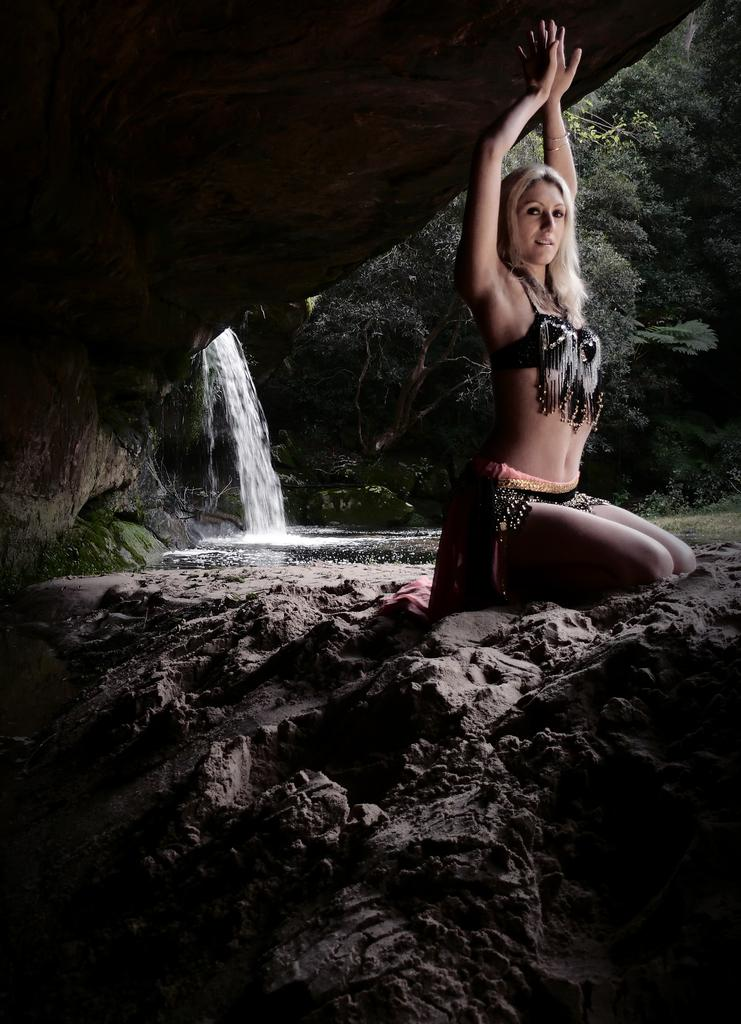Who or what is present in the image? There is a person in the image. What is the person wearing? The person is wearing clothes. What natural feature can be seen on the left side of the image? There is a waterfall on the left side of the image. What type of vegetation is on the right side of the image? There are trees on the right side of the image. How many shoes can be seen on the person's feet in the image? There is no information about shoes in the image, as the provided facts only mention that the person is wearing clothes. 